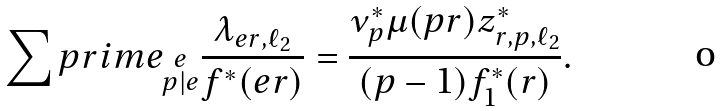Convert formula to latex. <formula><loc_0><loc_0><loc_500><loc_500>\sum p r i m e _ { \substack { e \\ p | e } } \frac { \lambda _ { e r , \ell _ { 2 } } } { f ^ { * } ( e r ) } = \frac { \nu ^ { * } _ { p } \mu ( p r ) z ^ { * } _ { r , p , \ell _ { 2 } } } { ( p - 1 ) f _ { 1 } ^ { * } ( r ) } .</formula> 